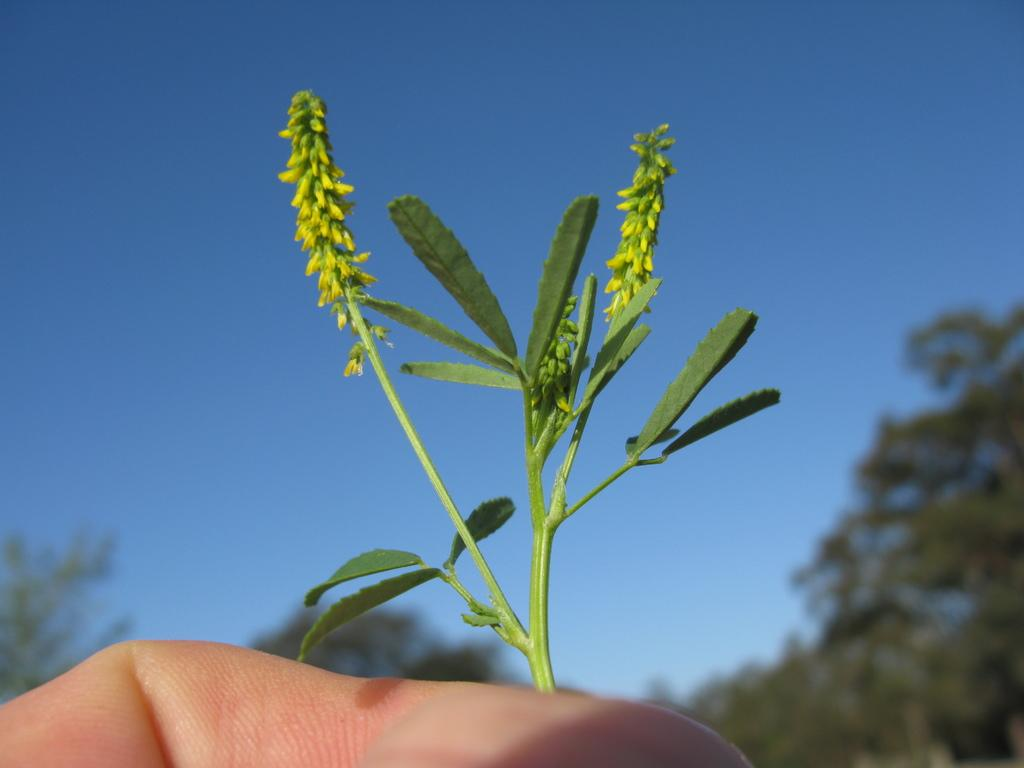What is the person in the image holding? There is a hand holding a small plant in the image. What can be seen in the background of the image? There are trees in the background of the image. What color is the sky in the image? The sky is blue and visible at the top of the image. What type of government is depicted in the image? There is no depiction of a government in the image; it features a hand holding a small plant, trees in the background, and a blue sky. Can you see a crook or stick in the image? There is no crook or stick present in the image. 